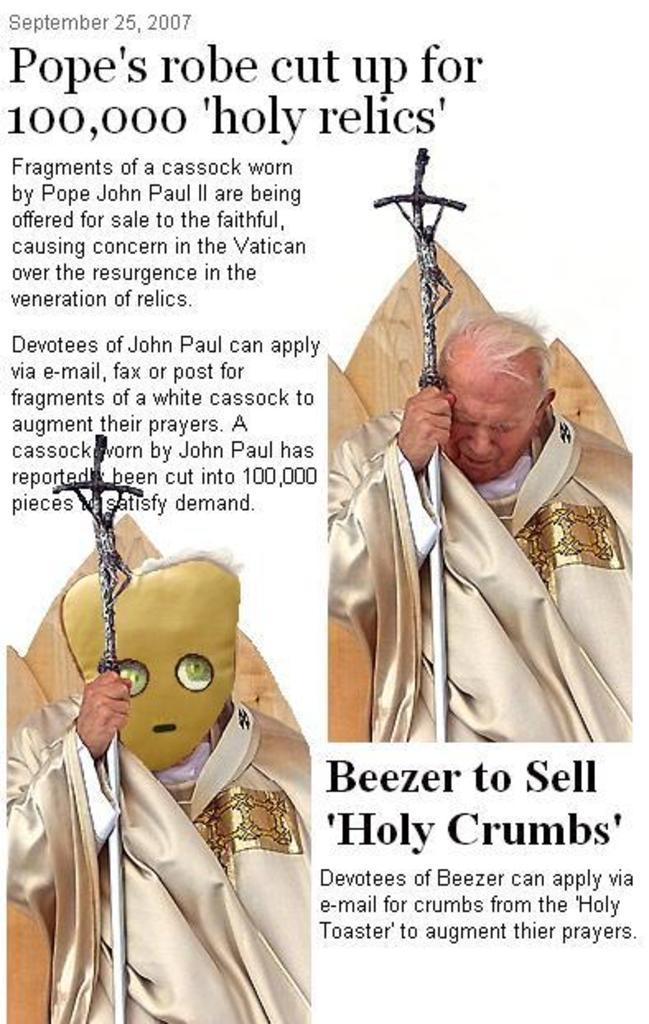Who is present in the image? There is a man in the image. What is the man doing in the image? The man is standing in the image. What object is the man holding in his hands? The man is holding an iron rod in his hands. Can you describe the iron rod further? Yes, there is writing on the iron rod. What type of bead is used to support the theory in the image? There is no bead or theory present in the image; it features a man holding an iron rod with writing on it. 